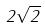<formula> <loc_0><loc_0><loc_500><loc_500>2 \sqrt { 2 }</formula> 